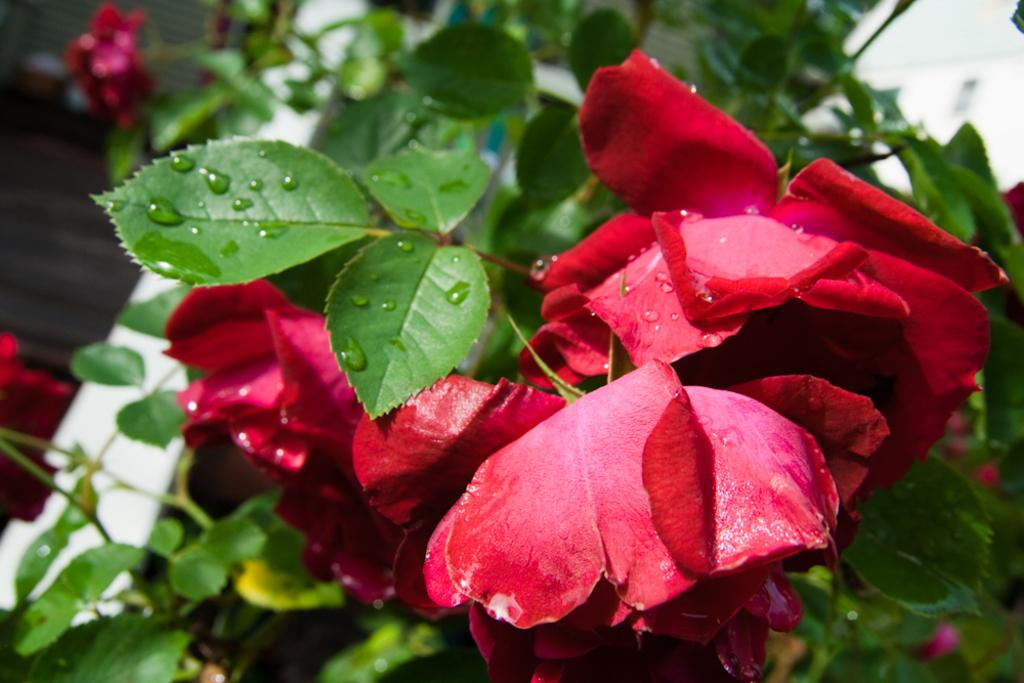What type of plant life can be seen in the image? There are flowers and leaves in the image. Can you describe the background of the image? There appears to be a wall at the top right corner of the image. What type of meat can be seen hanging from the wall in the image? There is no meat present in the image; it only features flowers, leaves, and a wall. 